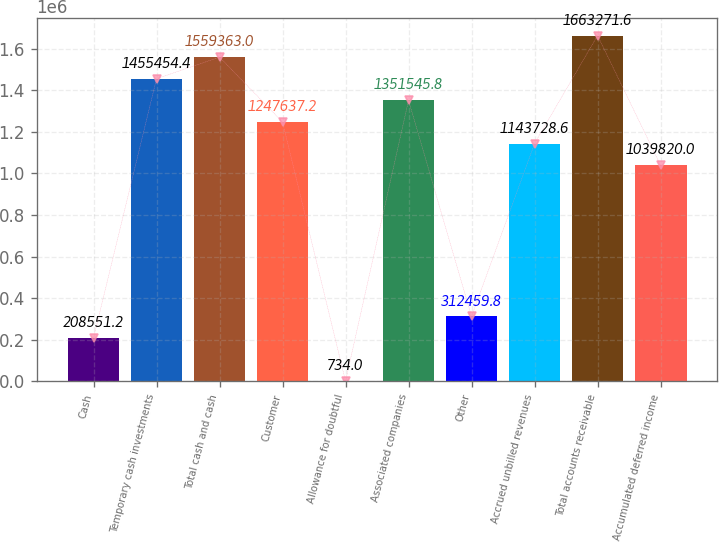Convert chart. <chart><loc_0><loc_0><loc_500><loc_500><bar_chart><fcel>Cash<fcel>Temporary cash investments<fcel>Total cash and cash<fcel>Customer<fcel>Allowance for doubtful<fcel>Associated companies<fcel>Other<fcel>Accrued unbilled revenues<fcel>Total accounts receivable<fcel>Accumulated deferred income<nl><fcel>208551<fcel>1.45545e+06<fcel>1.55936e+06<fcel>1.24764e+06<fcel>734<fcel>1.35155e+06<fcel>312460<fcel>1.14373e+06<fcel>1.66327e+06<fcel>1.03982e+06<nl></chart> 